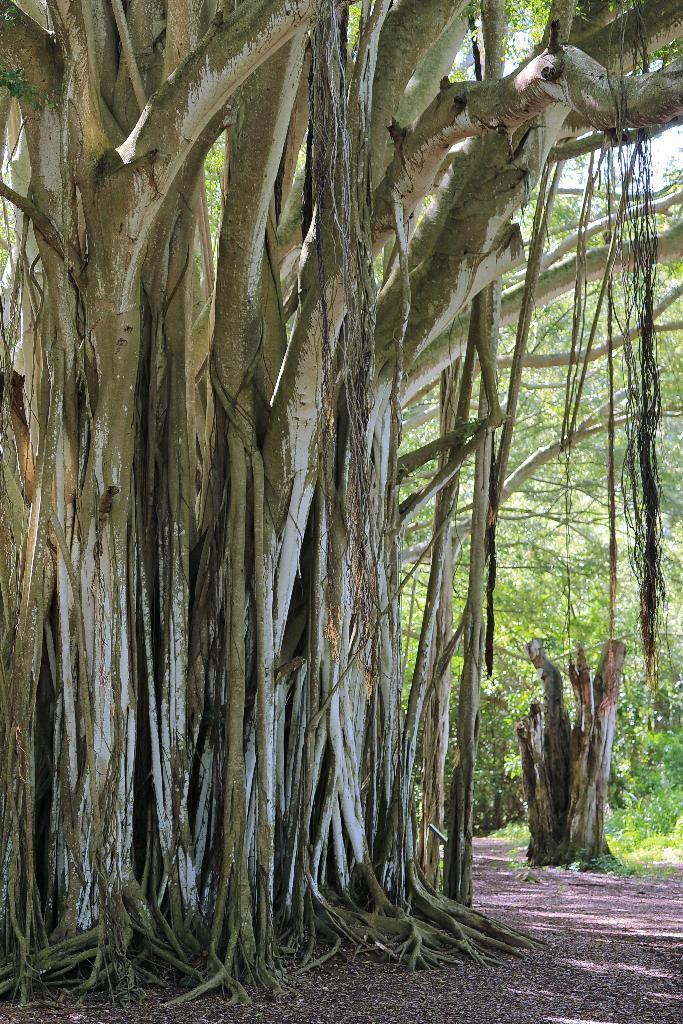What is the main subject in the foreground of the image? There is a tree trunk and roots hanging in the foreground of the image. Can you describe the background of the image? There is another tree trunk and trees visible in the background of the image. What type of class is being held under the tree in the image? There is no class or people present in the image, only tree trunks and roots. Can you hear thunder in the image? There is no sound or indication of thunder in the image; it is a still photograph. 